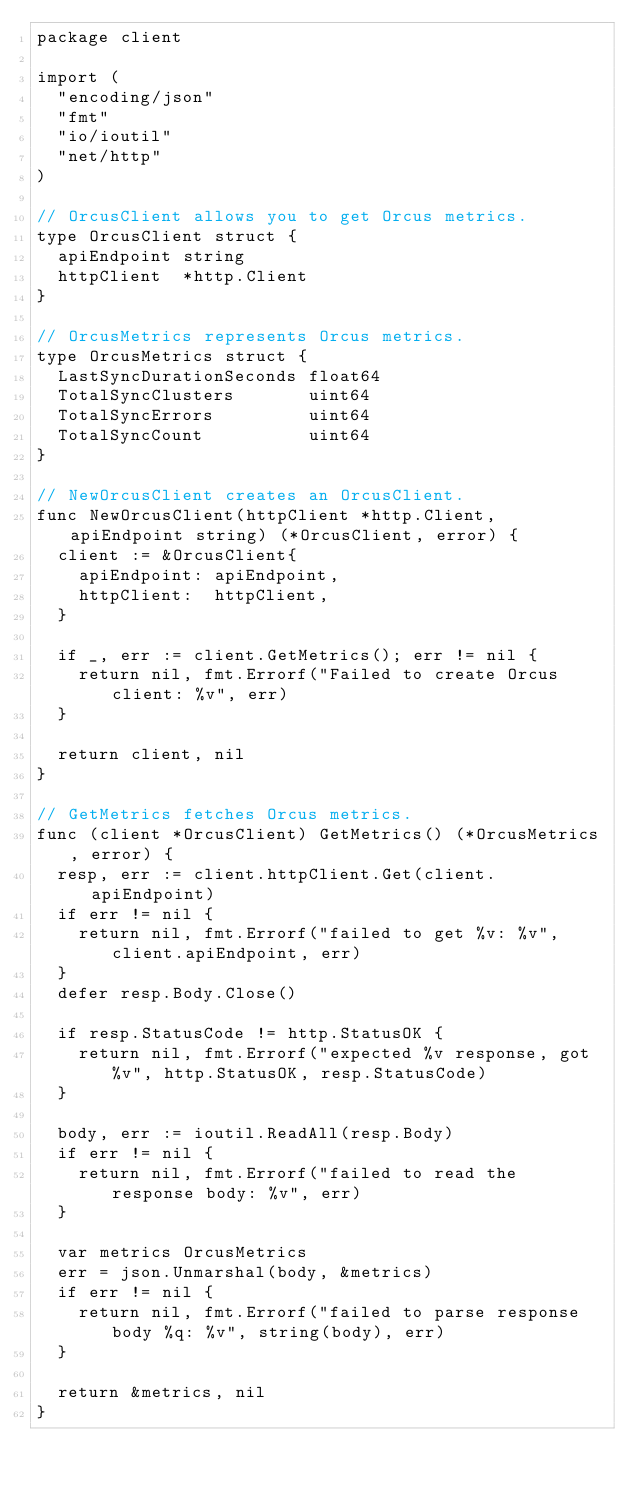Convert code to text. <code><loc_0><loc_0><loc_500><loc_500><_Go_>package client

import (
	"encoding/json"
	"fmt"
	"io/ioutil"
	"net/http"
)

// OrcusClient allows you to get Orcus metrics.
type OrcusClient struct {
	apiEndpoint string
	httpClient  *http.Client
}

// OrcusMetrics represents Orcus metrics.
type OrcusMetrics struct {
	LastSyncDurationSeconds float64
	TotalSyncClusters       uint64
	TotalSyncErrors         uint64
	TotalSyncCount          uint64
}

// NewOrcusClient creates an OrcusClient.
func NewOrcusClient(httpClient *http.Client, apiEndpoint string) (*OrcusClient, error) {
	client := &OrcusClient{
		apiEndpoint: apiEndpoint,
		httpClient:  httpClient,
	}

	if _, err := client.GetMetrics(); err != nil {
		return nil, fmt.Errorf("Failed to create Orcus client: %v", err)
	}

	return client, nil
}

// GetMetrics fetches Orcus metrics.
func (client *OrcusClient) GetMetrics() (*OrcusMetrics, error) {
	resp, err := client.httpClient.Get(client.apiEndpoint)
	if err != nil {
		return nil, fmt.Errorf("failed to get %v: %v", client.apiEndpoint, err)
	}
	defer resp.Body.Close()

	if resp.StatusCode != http.StatusOK {
		return nil, fmt.Errorf("expected %v response, got %v", http.StatusOK, resp.StatusCode)
	}

	body, err := ioutil.ReadAll(resp.Body)
	if err != nil {
		return nil, fmt.Errorf("failed to read the response body: %v", err)
	}

	var metrics OrcusMetrics
	err = json.Unmarshal(body, &metrics)
	if err != nil {
		return nil, fmt.Errorf("failed to parse response body %q: %v", string(body), err)
	}

	return &metrics, nil
}
</code> 